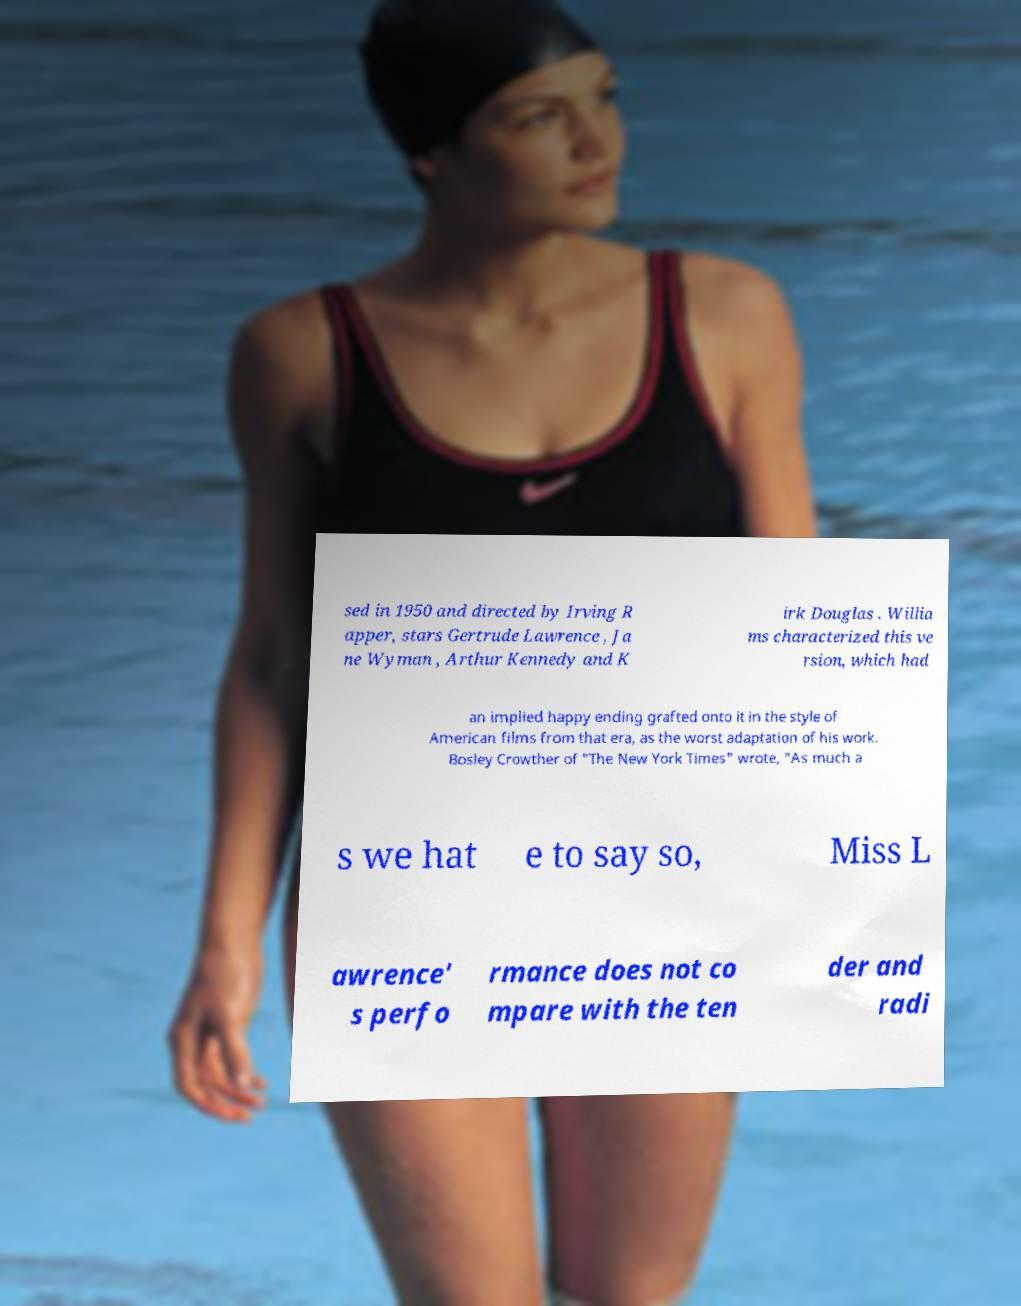There's text embedded in this image that I need extracted. Can you transcribe it verbatim? sed in 1950 and directed by Irving R apper, stars Gertrude Lawrence , Ja ne Wyman , Arthur Kennedy and K irk Douglas . Willia ms characterized this ve rsion, which had an implied happy ending grafted onto it in the style of American films from that era, as the worst adaptation of his work. Bosley Crowther of "The New York Times" wrote, "As much a s we hat e to say so, Miss L awrence' s perfo rmance does not co mpare with the ten der and radi 